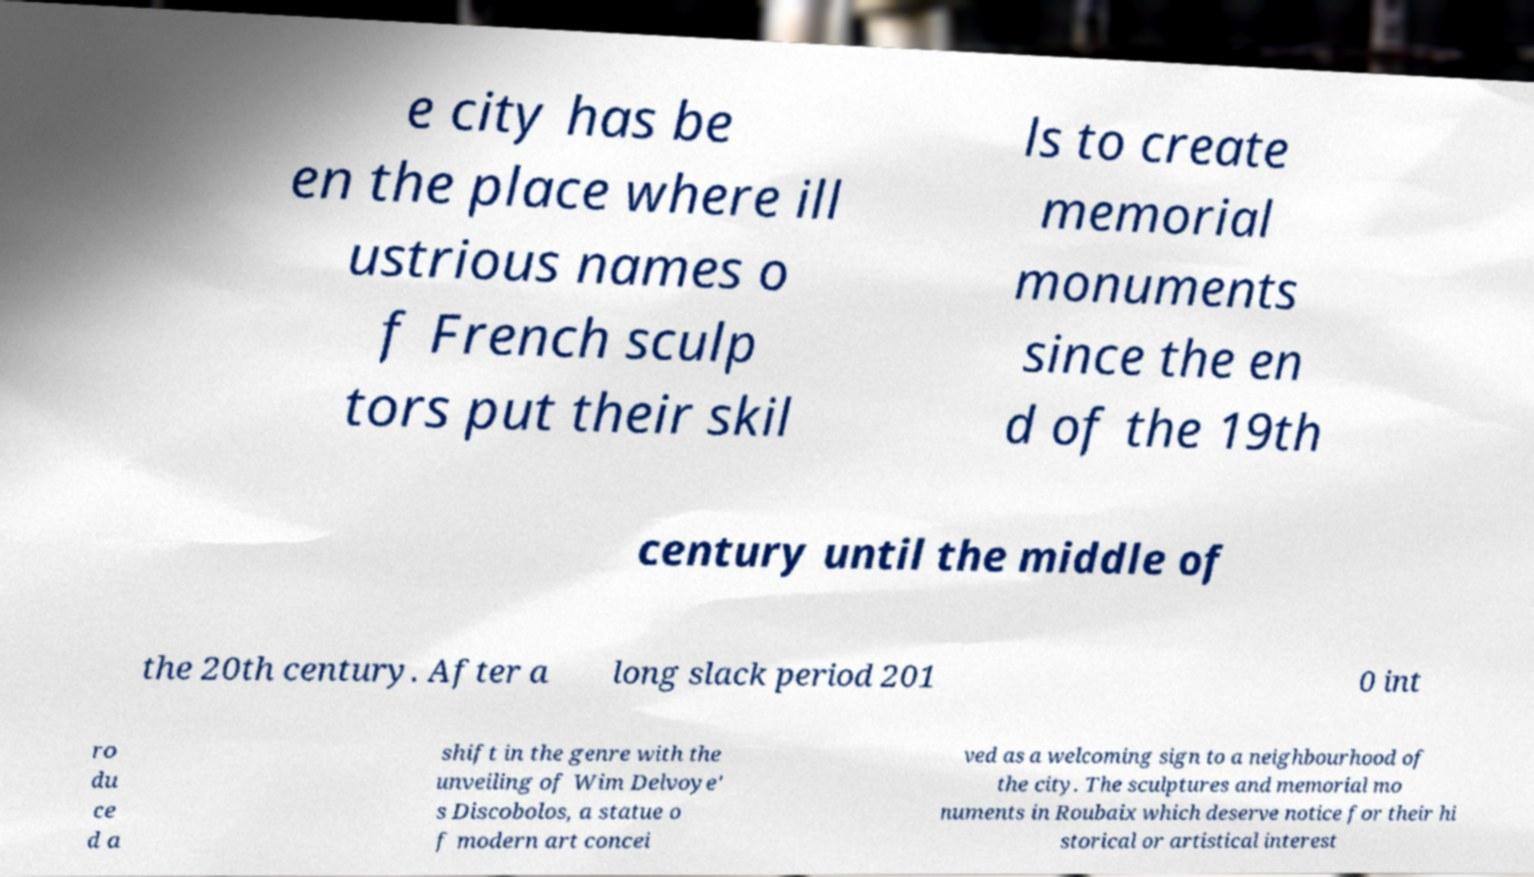Can you accurately transcribe the text from the provided image for me? e city has be en the place where ill ustrious names o f French sculp tors put their skil ls to create memorial monuments since the en d of the 19th century until the middle of the 20th century. After a long slack period 201 0 int ro du ce d a shift in the genre with the unveiling of Wim Delvoye' s Discobolos, a statue o f modern art concei ved as a welcoming sign to a neighbourhood of the city. The sculptures and memorial mo numents in Roubaix which deserve notice for their hi storical or artistical interest 